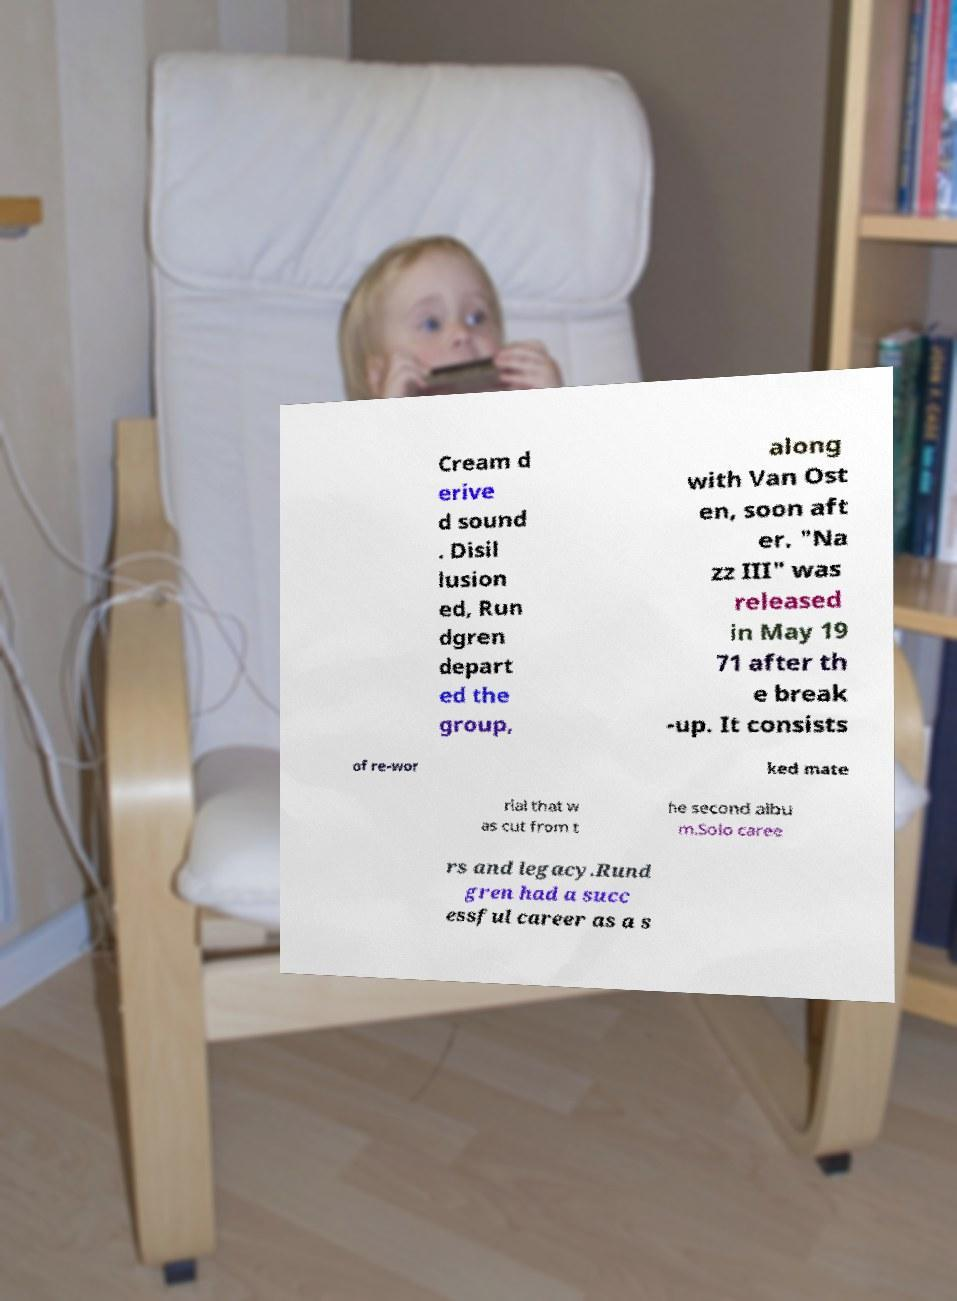For documentation purposes, I need the text within this image transcribed. Could you provide that? Cream d erive d sound . Disil lusion ed, Run dgren depart ed the group, along with Van Ost en, soon aft er. "Na zz III" was released in May 19 71 after th e break -up. It consists of re-wor ked mate rial that w as cut from t he second albu m.Solo caree rs and legacy.Rund gren had a succ essful career as a s 